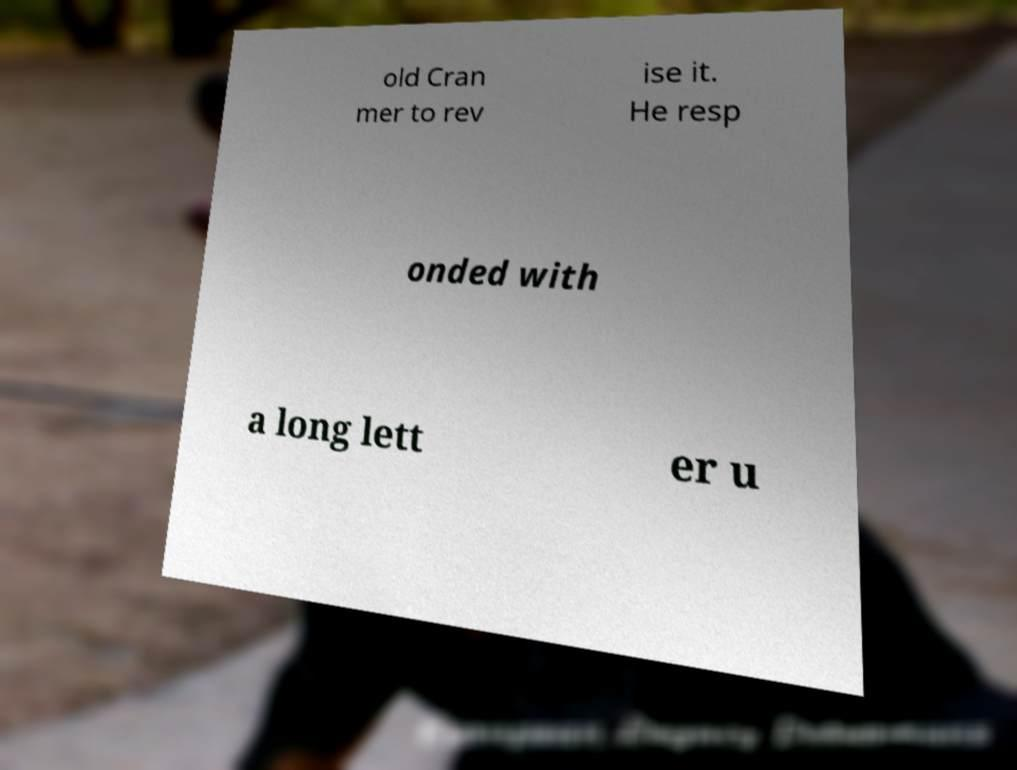Could you extract and type out the text from this image? old Cran mer to rev ise it. He resp onded with a long lett er u 